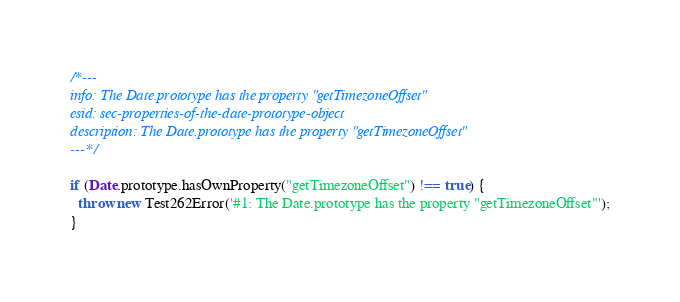Convert code to text. <code><loc_0><loc_0><loc_500><loc_500><_JavaScript_>/*---
info: The Date.prototype has the property "getTimezoneOffset"
esid: sec-properties-of-the-date-prototype-object
description: The Date.prototype has the property "getTimezoneOffset"
---*/

if (Date.prototype.hasOwnProperty("getTimezoneOffset") !== true) {
  throw new Test262Error('#1: The Date.prototype has the property "getTimezoneOffset"');
}
</code> 